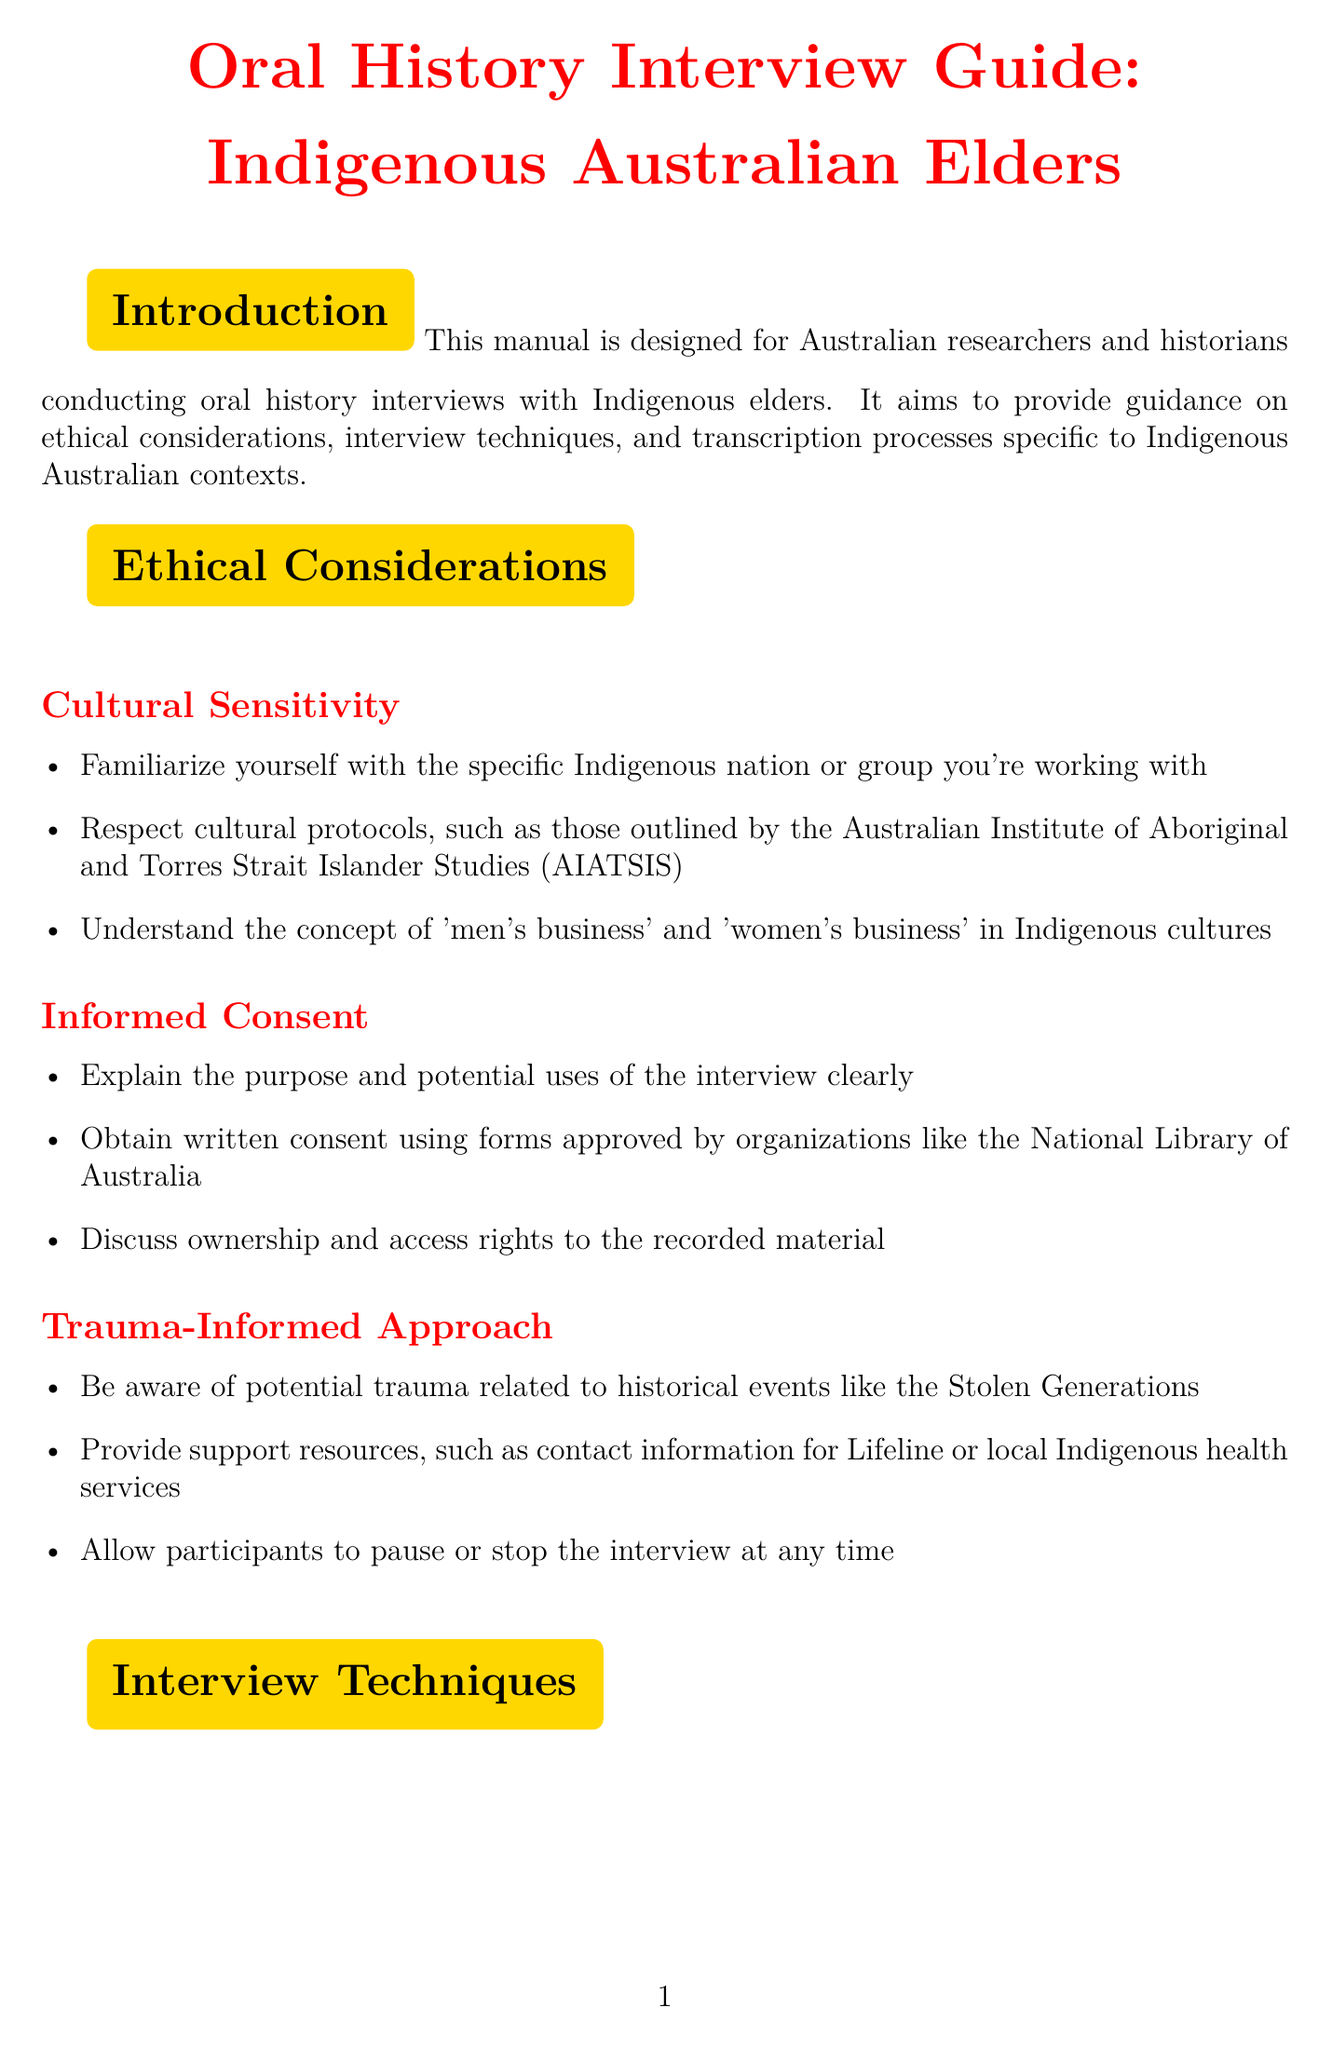what is the title of the manual? The title is provided at the beginning of the document and is "Oral History Interview Guide: Indigenous Australian Elders."
Answer: Oral History Interview Guide: Indigenous Australian Elders what resource outlines ethical research guidelines? The document lists a specific resource for ethical research guidelines, which is the "AIATSIS Guidelines for Ethical Research in Australian Indigenous Studies."
Answer: AIATSIS Guidelines for Ethical Research in Australian Indigenous Studies how many points are listed under Cultural Sensitivity? The section on Cultural Sensitivity includes three specific points outlined in the document.
Answer: 3 what equipment is recommended for recording interviews? The document specifies using digital recording equipment such as the Zoom H4n Pro or Tascam DR-40X.
Answer: Zoom H4n Pro or Tascam DR-40X what approach should be taken to handle potential trauma during interviews? The document emphasizes the need for a trauma-informed approach when dealing with sensitive historical topics during interviews.
Answer: Trauma-Informed Approach what technique is suggested for questioning during interviews? The document recommends using the 'yarning' technique as a culturally appropriate form of conversation.
Answer: yarning how should transcripts be reviewed for language accuracy? The document advises having the transcript reviewed by a native speaker of the Indigenous language if applicable.
Answer: native speaker what is one guideline for archiving oral history interviews? The document suggests following the National Library of Australia's guidelines for oral history preservation as a key archiving guideline.
Answer: National Library of Australia's guidelines 